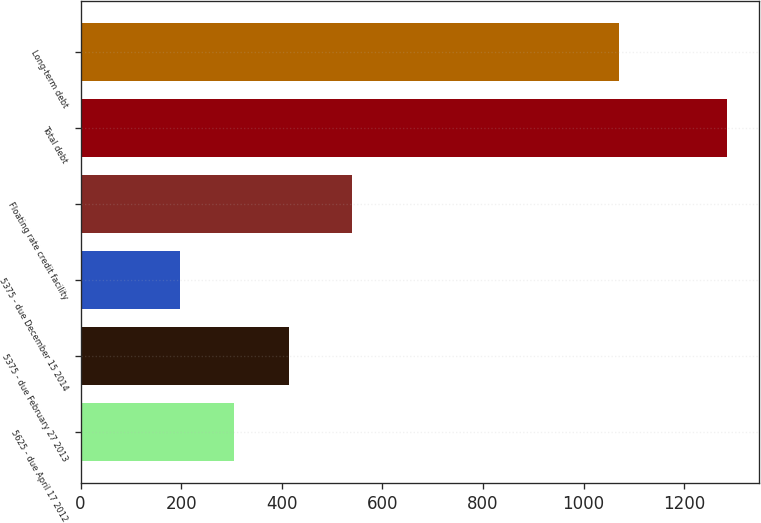<chart> <loc_0><loc_0><loc_500><loc_500><bar_chart><fcel>5625 - due April 17 2012<fcel>5375 - due February 27 2013<fcel>5375 - due December 15 2014<fcel>Floating rate credit facility<fcel>Total debt<fcel>Long-term debt<nl><fcel>305.86<fcel>414.62<fcel>197.1<fcel>539<fcel>1284.7<fcel>1069.6<nl></chart> 